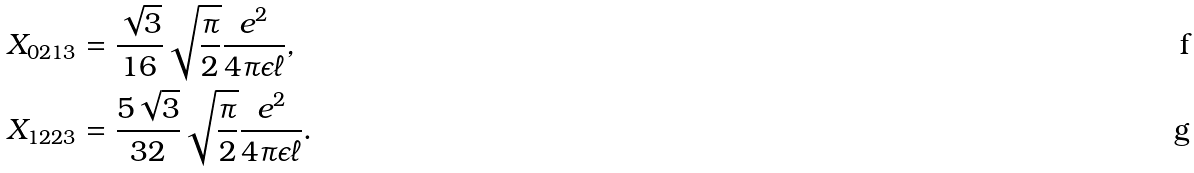<formula> <loc_0><loc_0><loc_500><loc_500>X _ { 0 2 1 3 } & = \frac { \sqrt { 3 } } { 1 6 } \sqrt { \frac { \pi } { 2 } } \frac { e ^ { 2 } } { 4 \pi \epsilon \ell } , \\ X _ { 1 2 2 3 } & = \frac { 5 \sqrt { 3 } } { 3 2 } \sqrt { \frac { \pi } { 2 } } \frac { e ^ { 2 } } { 4 \pi \epsilon \ell } .</formula> 